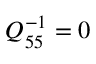Convert formula to latex. <formula><loc_0><loc_0><loc_500><loc_500>Q _ { 5 5 } ^ { - 1 } = 0</formula> 